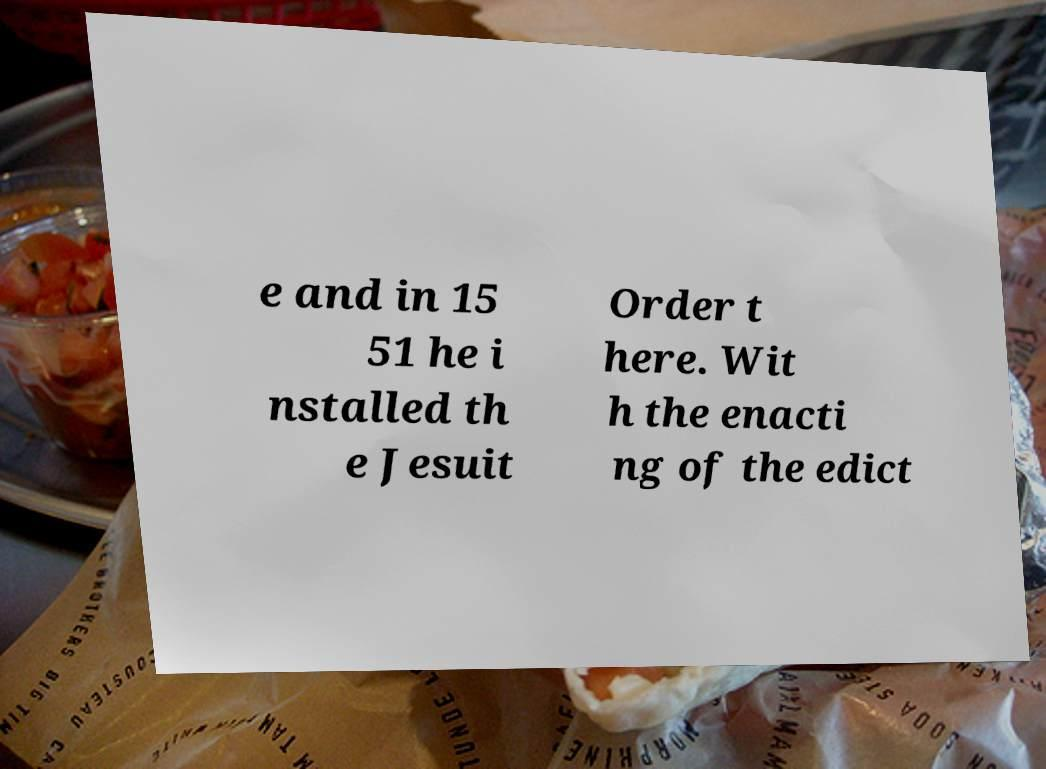I need the written content from this picture converted into text. Can you do that? e and in 15 51 he i nstalled th e Jesuit Order t here. Wit h the enacti ng of the edict 